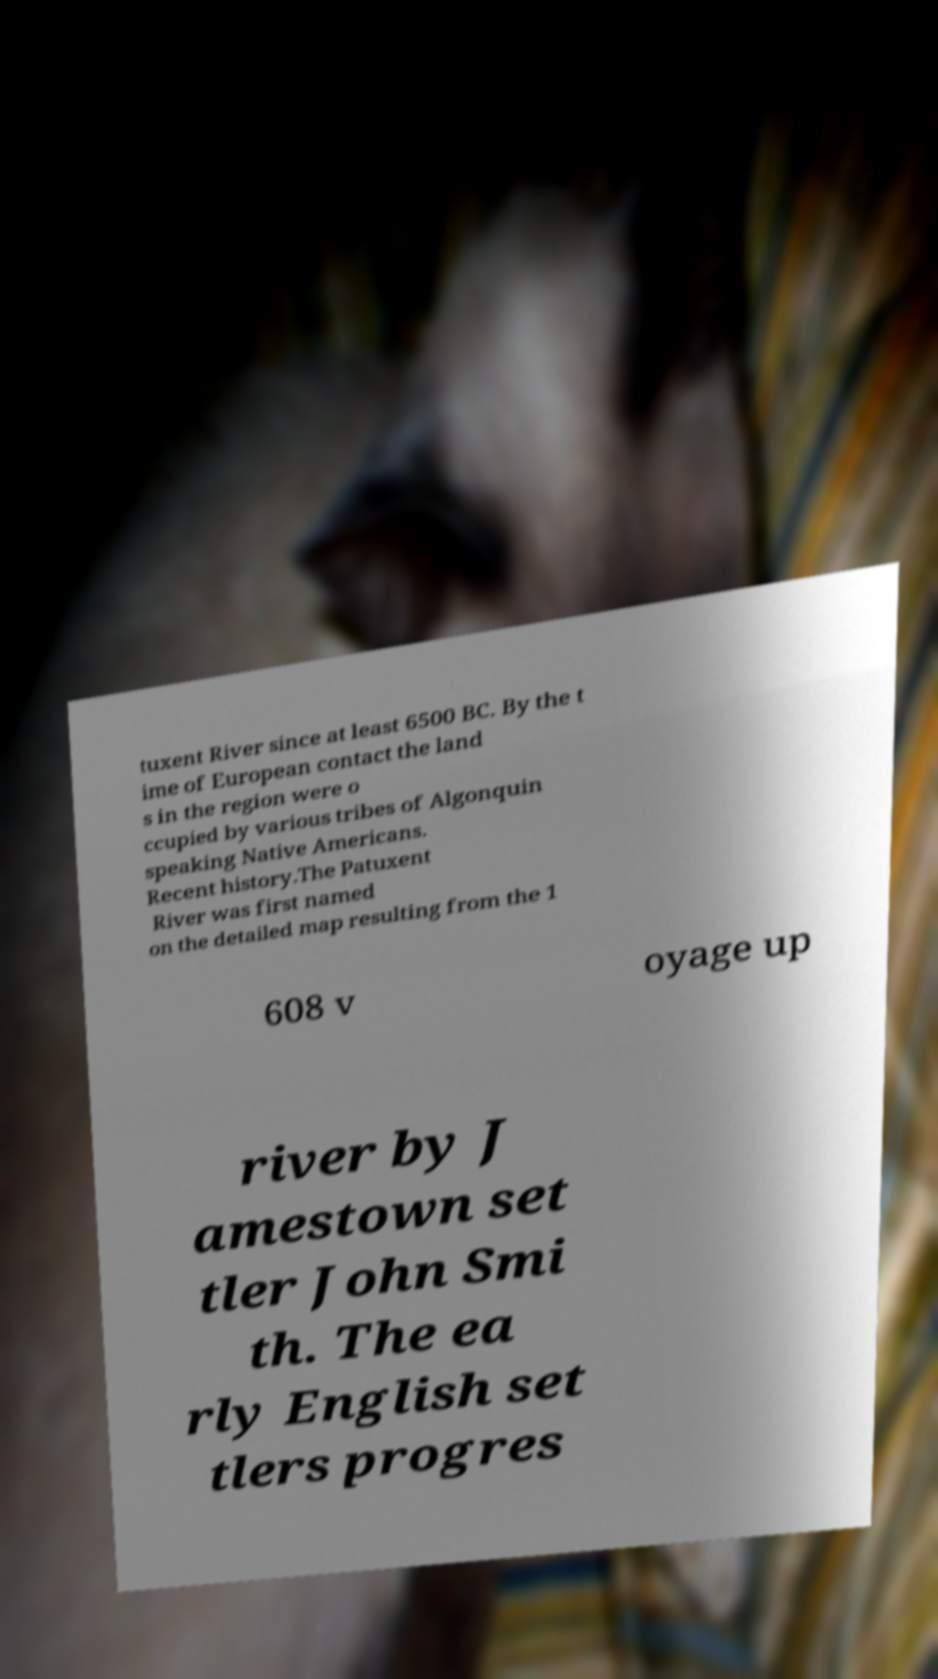Could you extract and type out the text from this image? tuxent River since at least 6500 BC. By the t ime of European contact the land s in the region were o ccupied by various tribes of Algonquin speaking Native Americans. Recent history.The Patuxent River was first named on the detailed map resulting from the 1 608 v oyage up river by J amestown set tler John Smi th. The ea rly English set tlers progres 